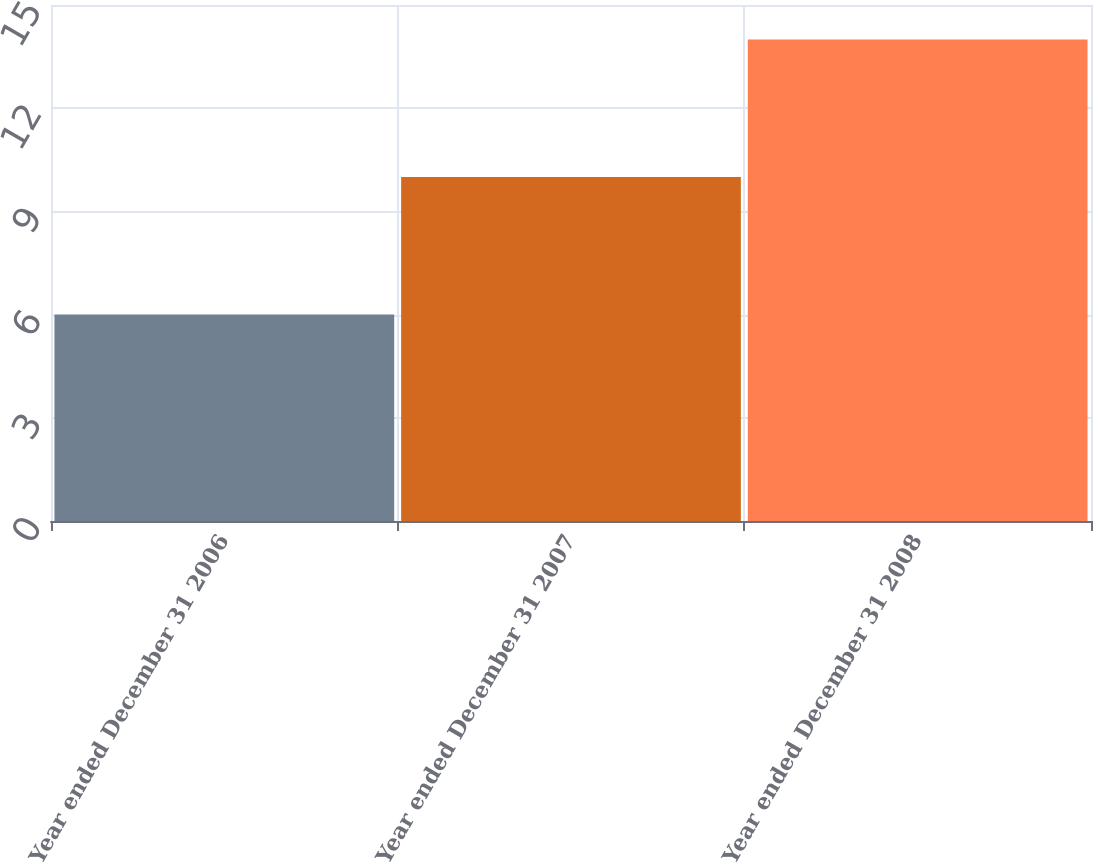Convert chart. <chart><loc_0><loc_0><loc_500><loc_500><bar_chart><fcel>Year ended December 31 2006<fcel>Year ended December 31 2007<fcel>Year ended December 31 2008<nl><fcel>6<fcel>10<fcel>14<nl></chart> 